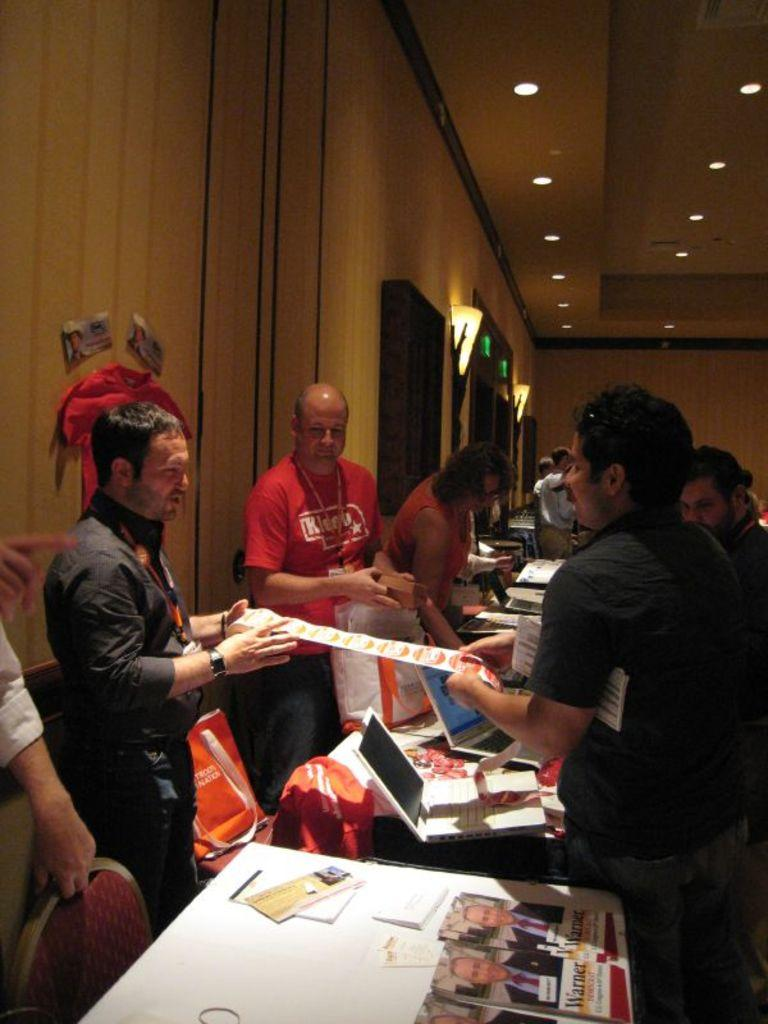<image>
Summarize the visual content of the image. Several people at what looks like a trade show with copies of warner magazine on the table. 